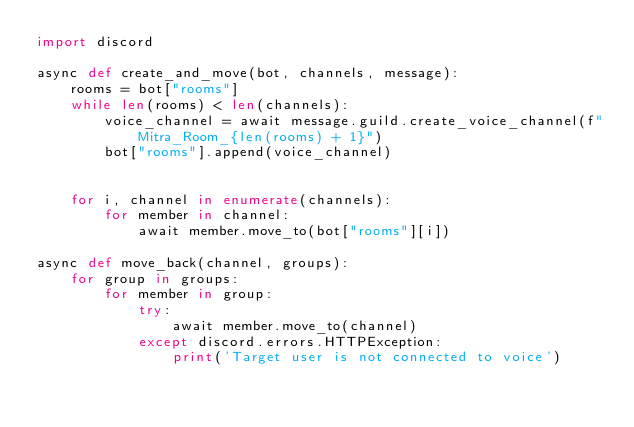<code> <loc_0><loc_0><loc_500><loc_500><_Python_>import discord

async def create_and_move(bot, channels, message):
    rooms = bot["rooms"]
    while len(rooms) < len(channels):
        voice_channel = await message.guild.create_voice_channel(f"Mitra_Room_{len(rooms) + 1}")
        bot["rooms"].append(voice_channel)


    for i, channel in enumerate(channels):
        for member in channel:
            await member.move_to(bot["rooms"][i])

async def move_back(channel, groups):
    for group in groups:
        for member in group:
            try:
                await member.move_to(channel)
            except discord.errors.HTTPException:
                print('Target user is not connected to voice')
</code> 